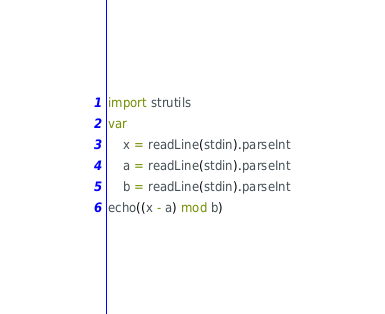Convert code to text. <code><loc_0><loc_0><loc_500><loc_500><_Nim_>import strutils
var
    x = readLine(stdin).parseInt
    a = readLine(stdin).parseInt
    b = readLine(stdin).parseInt
echo((x - a) mod b)</code> 